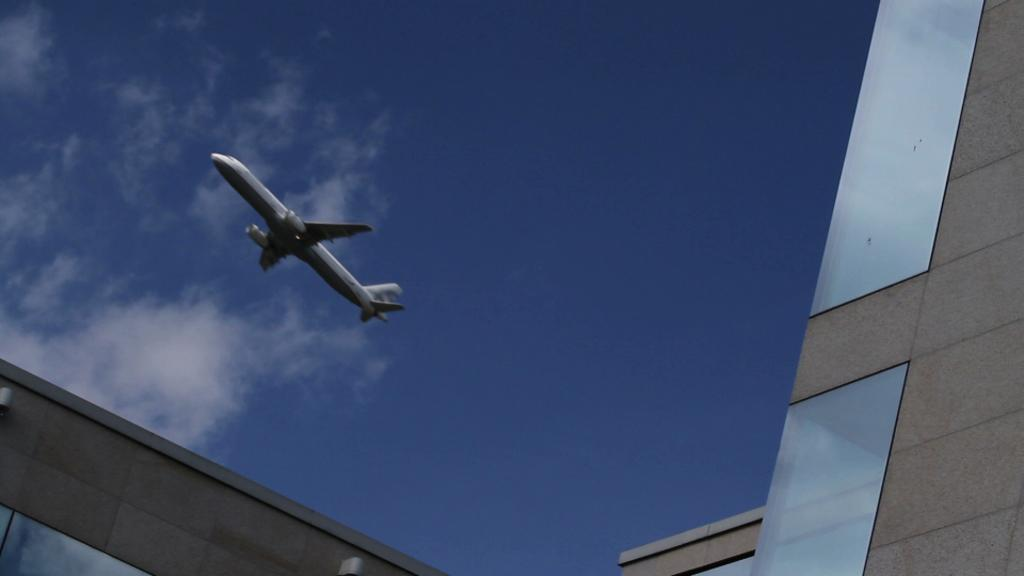What is the main subject of the image? The main subject of the image is a plane flying in the air. What can be seen in the background of the image? There are clouds in the sky in the background. What structure is located on the right side of the image? There is a building on the right side of the image. How does the stranger feel about the plane bursting into flames in the image? There is no stranger or indication of a plane bursting into flames in the image. 